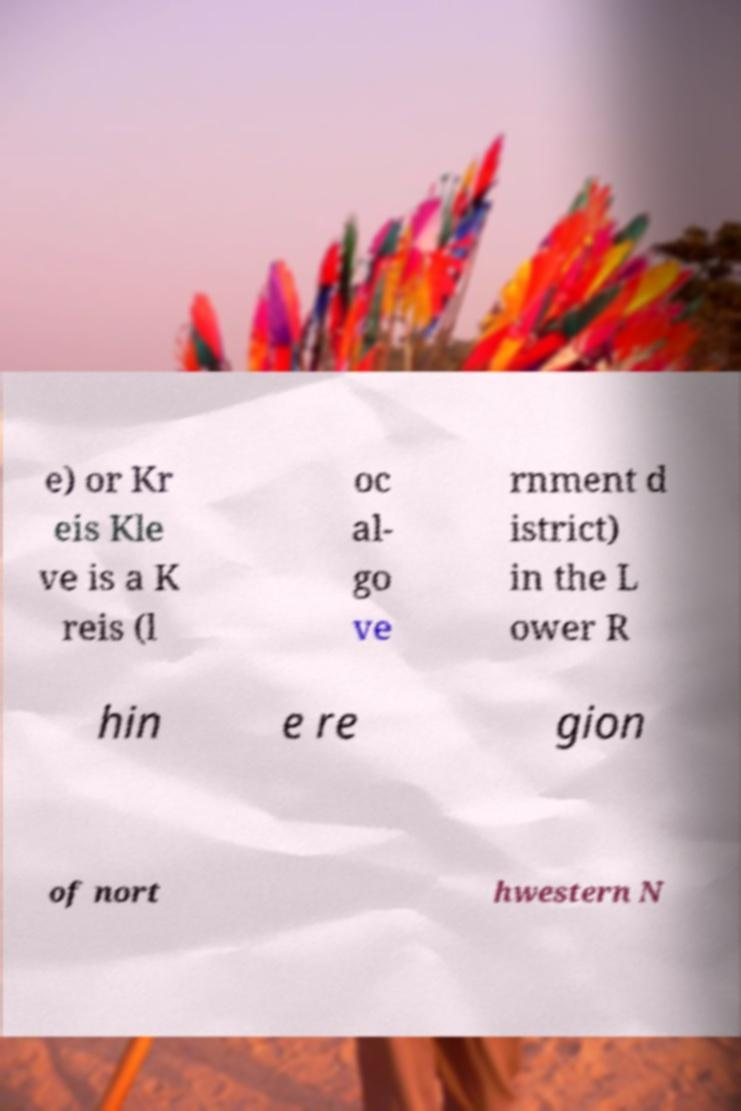For documentation purposes, I need the text within this image transcribed. Could you provide that? e) or Kr eis Kle ve is a K reis (l oc al- go ve rnment d istrict) in the L ower R hin e re gion of nort hwestern N 